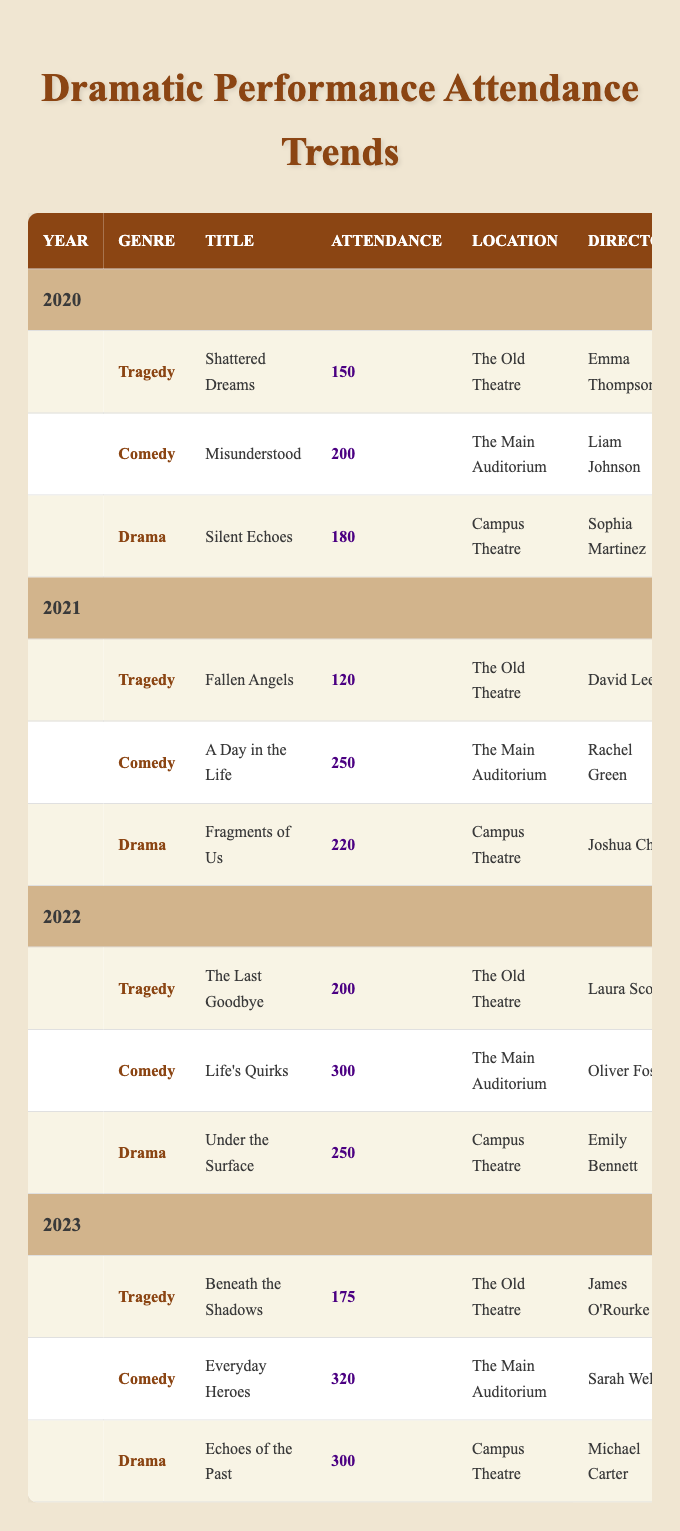What was the highest attendance for a comedy performance? The highest attendance for a comedy performance was in 2023 with the title "Everyday Heroes," which had 320 attendees.
Answer: 320 Which director had the most popular drama in 2022? In 2022, the most popular drama was "Under the Surface" directed by Emily Bennett, which had an attendance of 250.
Answer: Emily Bennett What is the difference in attendance between the best and the worst tragedy performances? The best tragedy in 2022 "The Last Goodbye" had 200 attendees, and the worst tragedy in 2021 "Fallen Angels" had 120 attendees. The difference is 200 - 120 = 80.
Answer: 80 Was there a comedy performance in 2021 that had more attendees than any tragedy in 2023? The comedy performance in 2021 "A Day in the Life" had 250 attendees, which is more than the tragedy performance in 2023 "Beneath the Shadows" that had 175 attendees. Therefore, the statement is true.
Answer: Yes What was the total attendance across all genres in the year 2020? For 2020, the total attendance was calculated as 150 (Tragedy) + 200 (Comedy) + 180 (Drama) = 530.
Answer: 530 In which year was the attendance for drama the highest? The highest attendance for drama was in 2023 with "Echoes of the Past," which had 300 attendees, compared to 250 in 2022 and 220 in 2021.
Answer: 2023 What percentage of total attendance in 2022 was from comedy performances? In 2022, the total attendance was 200 (Tragedy) + 300 (Comedy) + 250 (Drama) = 750. The percentage from comedy is (300 / 750) * 100 = 40%.
Answer: 40% Which genre had the lowest overall attendance in 2021? In 2021, tragedy had the lowest attendance with "Fallen Angels" having 120 attendees, while comedy had 250 and drama had 220.
Answer: Tragedy How many performances had attendance over 250 from 2020 to 2023? In 2021, "A Day in the Life" (250), in 2022 "Life's Quirks" (300), in 2023 "Everyday Heroes" (320) and "Echoes of the Past" (300) had attendance over 250. This sums up to 4 performances.
Answer: 4 